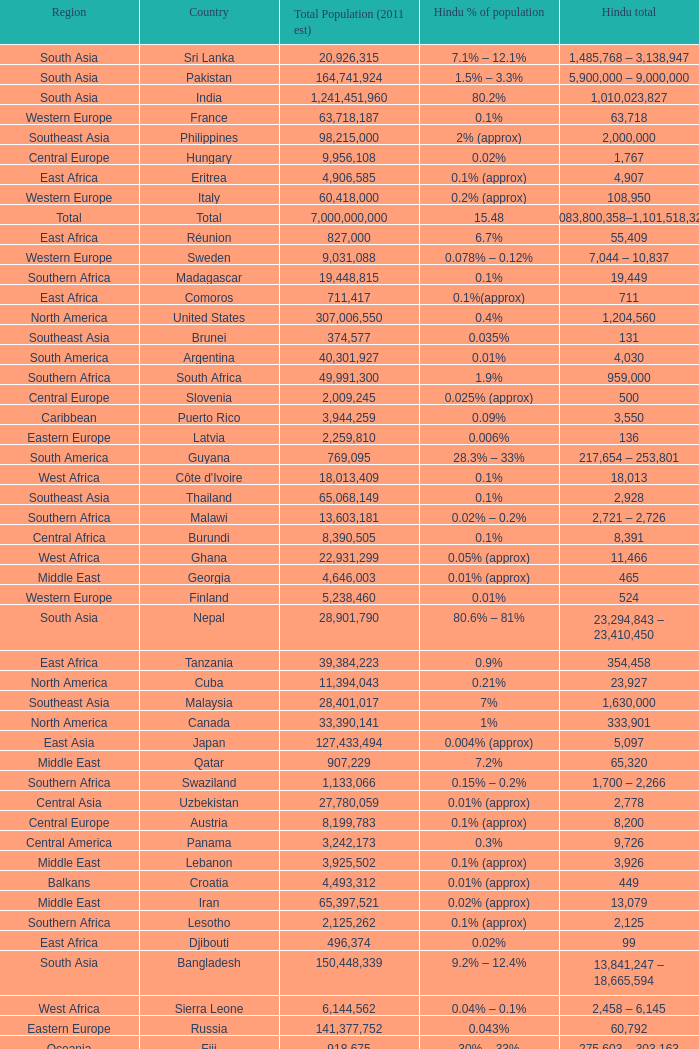Total Population (2011 est) larger than 30,262,610, and a Hindu total of 63,718 involves what country? France. 